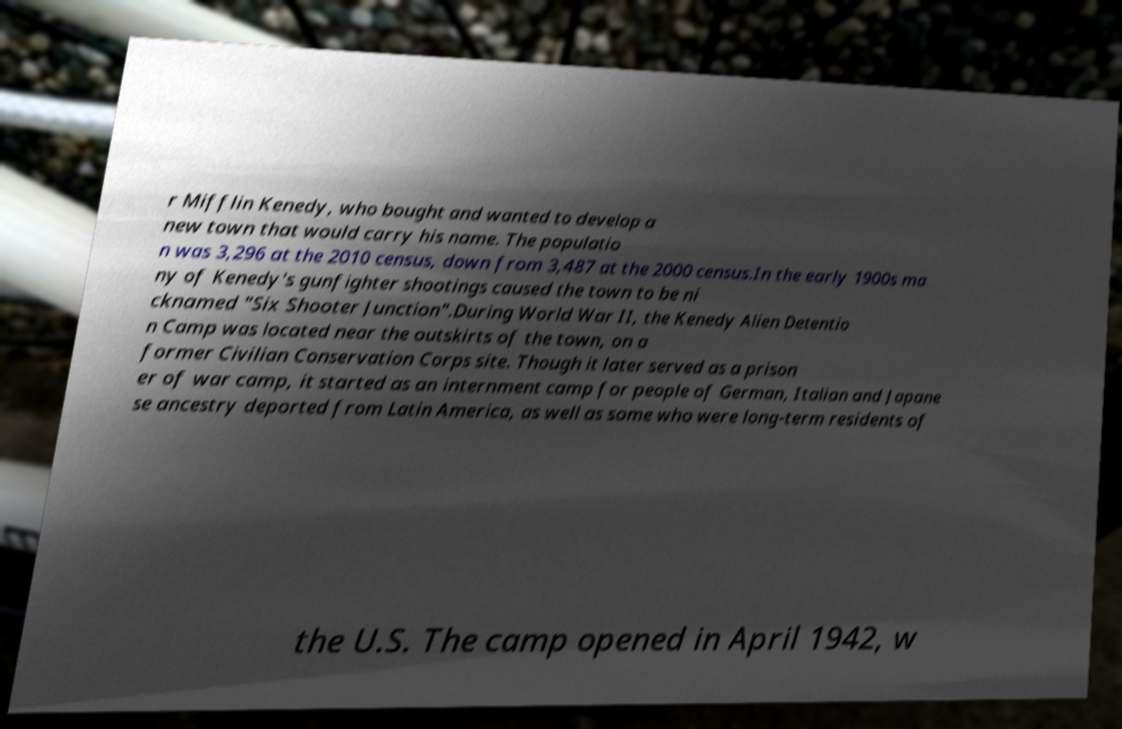Can you accurately transcribe the text from the provided image for me? r Mifflin Kenedy, who bought and wanted to develop a new town that would carry his name. The populatio n was 3,296 at the 2010 census, down from 3,487 at the 2000 census.In the early 1900s ma ny of Kenedy's gunfighter shootings caused the town to be ni cknamed "Six Shooter Junction".During World War II, the Kenedy Alien Detentio n Camp was located near the outskirts of the town, on a former Civilian Conservation Corps site. Though it later served as a prison er of war camp, it started as an internment camp for people of German, Italian and Japane se ancestry deported from Latin America, as well as some who were long-term residents of the U.S. The camp opened in April 1942, w 